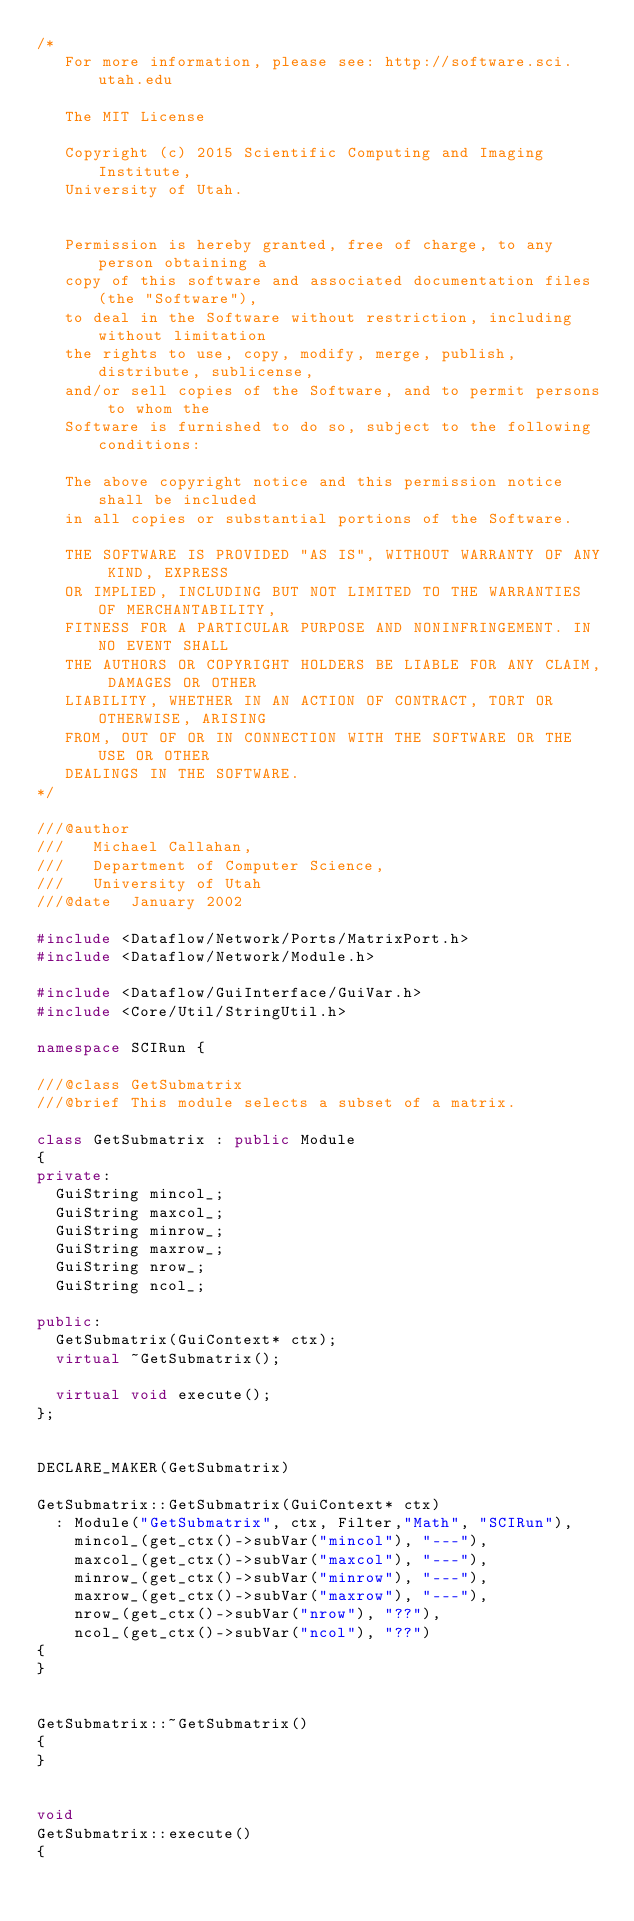Convert code to text. <code><loc_0><loc_0><loc_500><loc_500><_C++_>/*
   For more information, please see: http://software.sci.utah.edu

   The MIT License

   Copyright (c) 2015 Scientific Computing and Imaging Institute,
   University of Utah.

   
   Permission is hereby granted, free of charge, to any person obtaining a
   copy of this software and associated documentation files (the "Software"),
   to deal in the Software without restriction, including without limitation
   the rights to use, copy, modify, merge, publish, distribute, sublicense,
   and/or sell copies of the Software, and to permit persons to whom the
   Software is furnished to do so, subject to the following conditions:

   The above copyright notice and this permission notice shall be included
   in all copies or substantial portions of the Software.

   THE SOFTWARE IS PROVIDED "AS IS", WITHOUT WARRANTY OF ANY KIND, EXPRESS
   OR IMPLIED, INCLUDING BUT NOT LIMITED TO THE WARRANTIES OF MERCHANTABILITY,
   FITNESS FOR A PARTICULAR PURPOSE AND NONINFRINGEMENT. IN NO EVENT SHALL
   THE AUTHORS OR COPYRIGHT HOLDERS BE LIABLE FOR ANY CLAIM, DAMAGES OR OTHER
   LIABILITY, WHETHER IN AN ACTION OF CONTRACT, TORT OR OTHERWISE, ARISING
   FROM, OUT OF OR IN CONNECTION WITH THE SOFTWARE OR THE USE OR OTHER
   DEALINGS IN THE SOFTWARE.
*/

///@author
///   Michael Callahan,
///   Department of Computer Science,
///   University of Utah
///@date  January 2002

#include <Dataflow/Network/Ports/MatrixPort.h>
#include <Dataflow/Network/Module.h>

#include <Dataflow/GuiInterface/GuiVar.h>
#include <Core/Util/StringUtil.h>

namespace SCIRun {

///@class GetSubmatrix
///@brief This module selects a subset of a matrix.  

class GetSubmatrix : public Module
{
private:
  GuiString mincol_;
  GuiString maxcol_;
  GuiString minrow_;
  GuiString maxrow_;
  GuiString nrow_;
  GuiString ncol_;

public:
  GetSubmatrix(GuiContext* ctx);
  virtual ~GetSubmatrix();

  virtual void execute();
};


DECLARE_MAKER(GetSubmatrix)

GetSubmatrix::GetSubmatrix(GuiContext* ctx)
  : Module("GetSubmatrix", ctx, Filter,"Math", "SCIRun"),
    mincol_(get_ctx()->subVar("mincol"), "---"),
    maxcol_(get_ctx()->subVar("maxcol"), "---"),
    minrow_(get_ctx()->subVar("minrow"), "---"),
    maxrow_(get_ctx()->subVar("maxrow"), "---"),
    nrow_(get_ctx()->subVar("nrow"), "??"),
    ncol_(get_ctx()->subVar("ncol"), "??")
{
}


GetSubmatrix::~GetSubmatrix()
{
}


void
GetSubmatrix::execute()
{</code> 